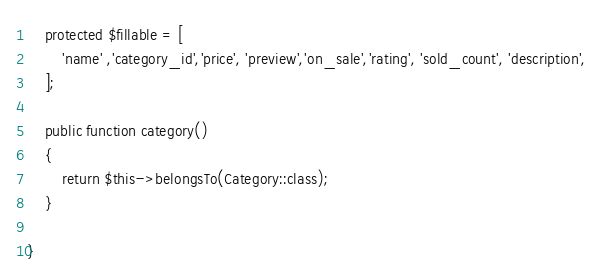Convert code to text. <code><loc_0><loc_0><loc_500><loc_500><_PHP_>
    protected $fillable = [
        'name' ,'category_id','price', 'preview','on_sale','rating', 'sold_count', 'description',
    ];

    public function category()
    {
        return $this->belongsTo(Category::class);
    }

}
</code> 